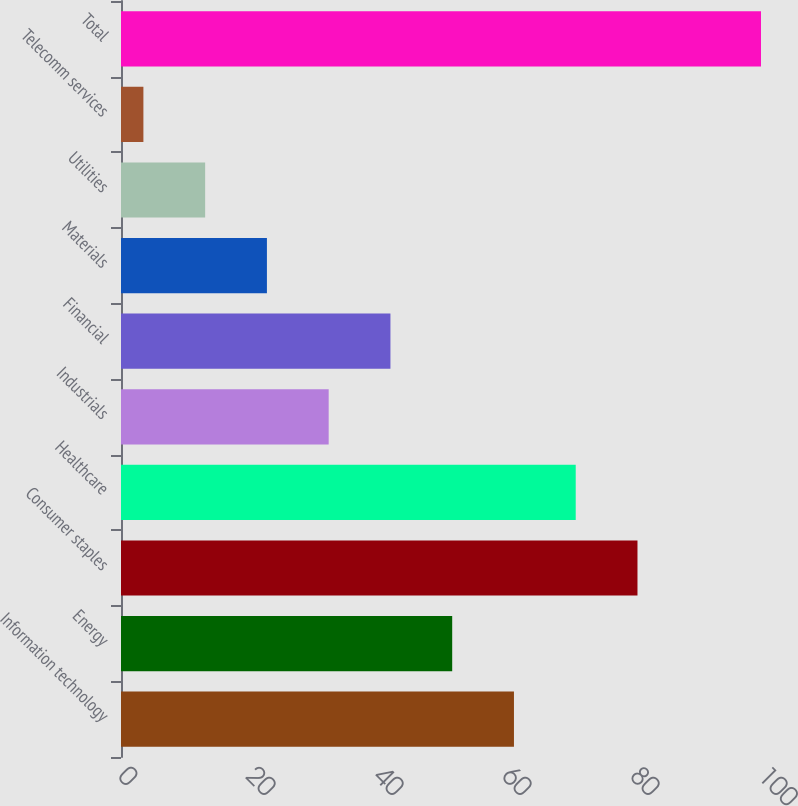Convert chart. <chart><loc_0><loc_0><loc_500><loc_500><bar_chart><fcel>Information technology<fcel>Energy<fcel>Consumer staples<fcel>Healthcare<fcel>Industrials<fcel>Financial<fcel>Materials<fcel>Utilities<fcel>Telecomm services<fcel>Total<nl><fcel>61.4<fcel>51.75<fcel>80.7<fcel>71.05<fcel>32.45<fcel>42.1<fcel>22.8<fcel>13.15<fcel>3.5<fcel>100<nl></chart> 